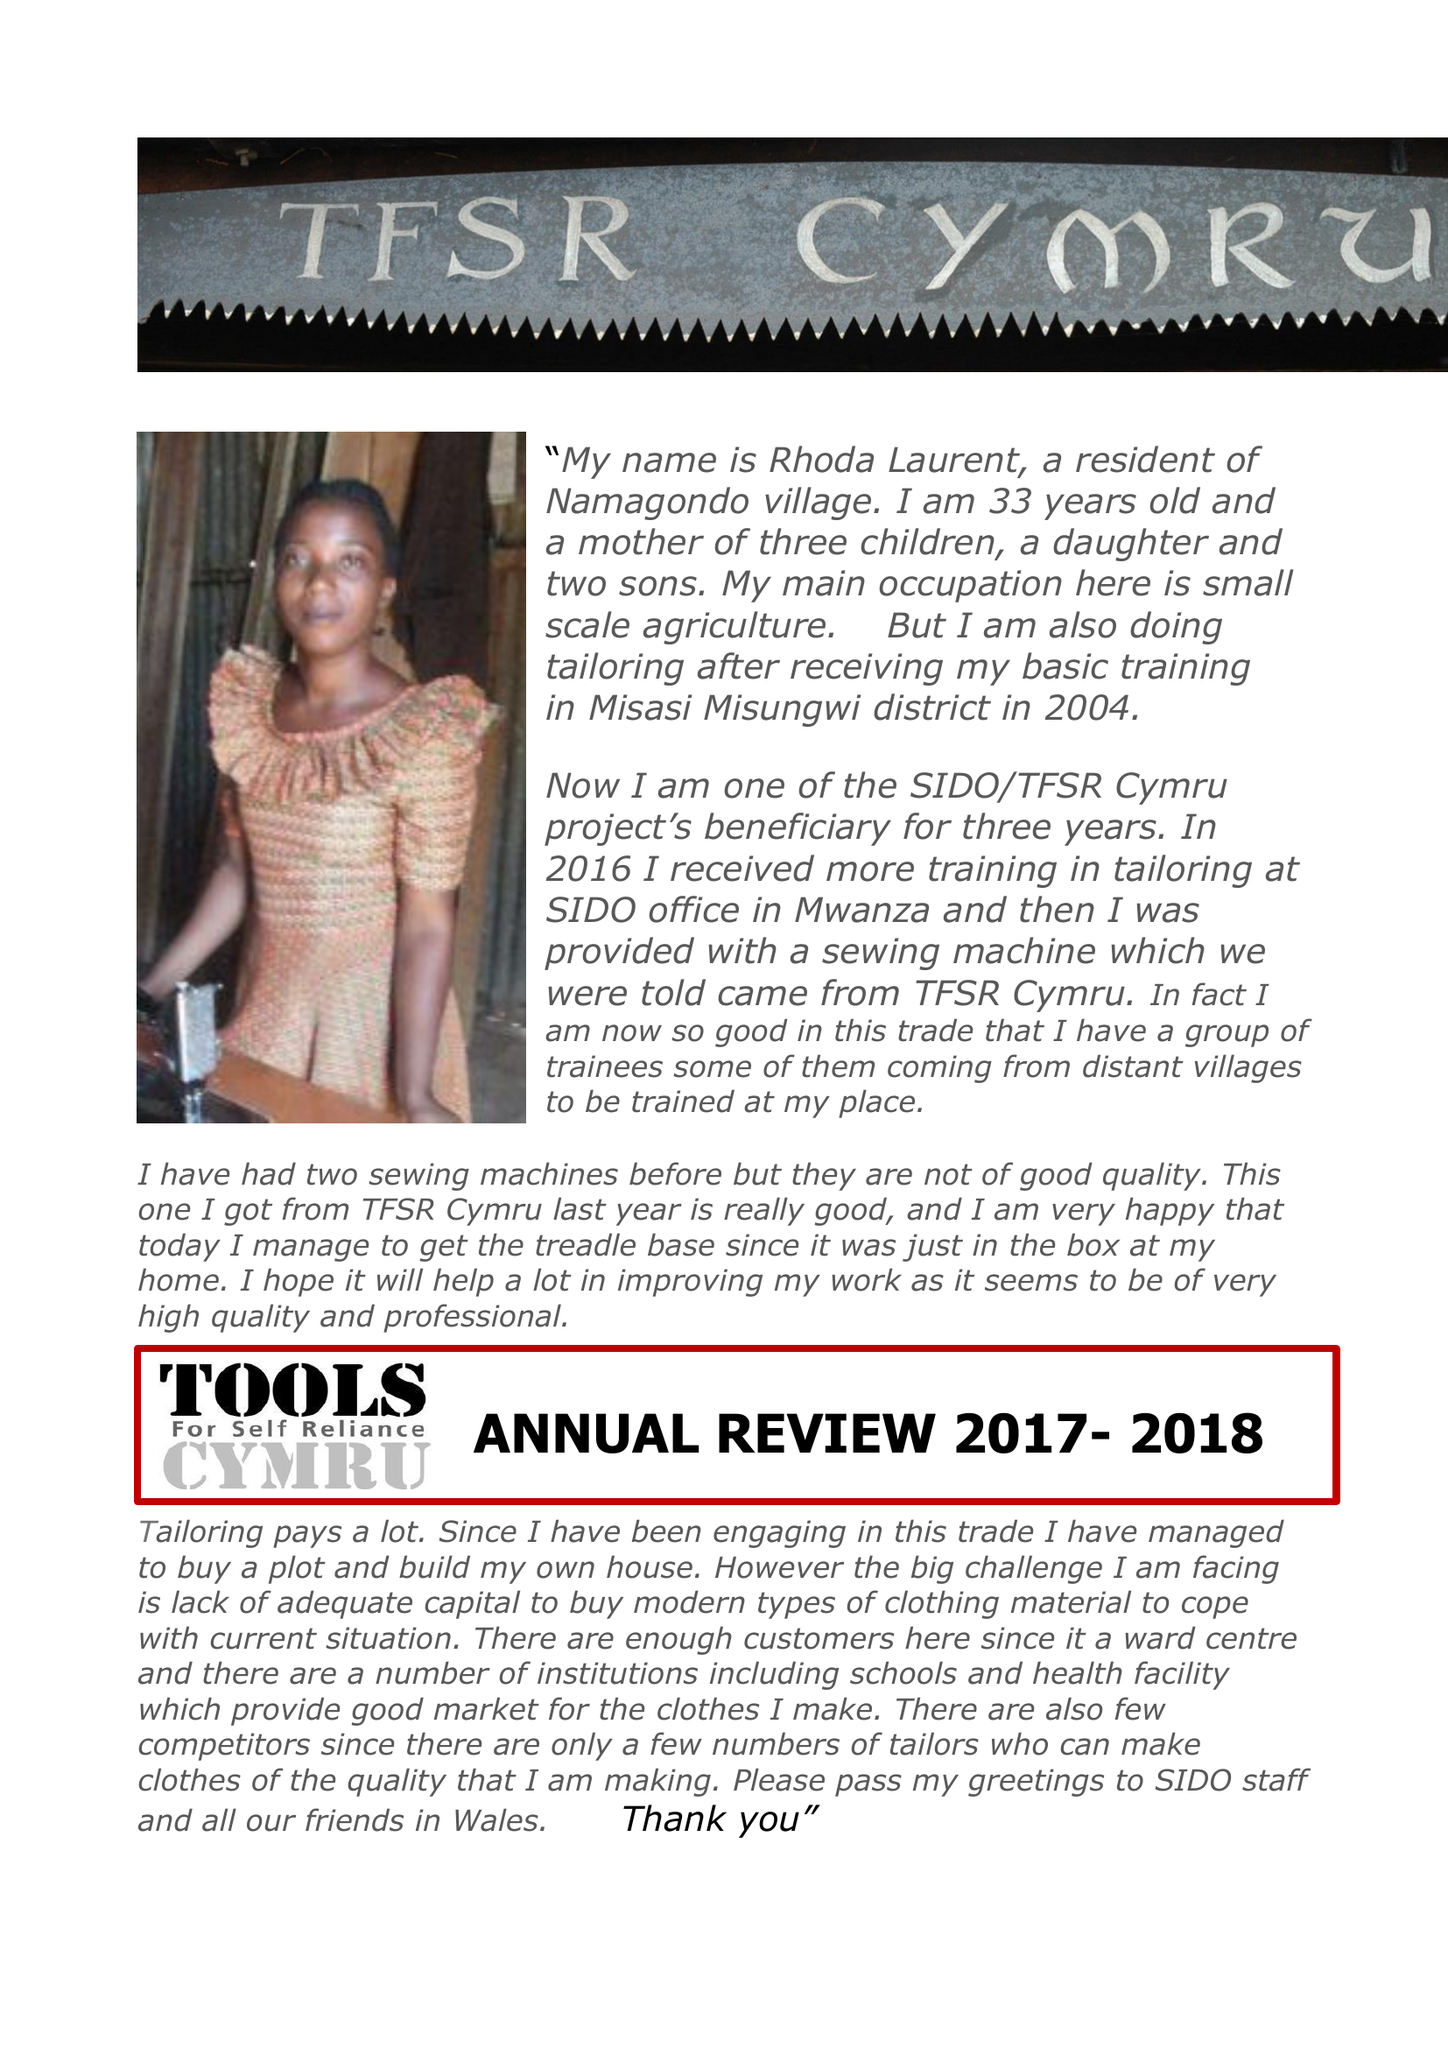What is the value for the income_annually_in_british_pounds?
Answer the question using a single word or phrase. 75545.00 